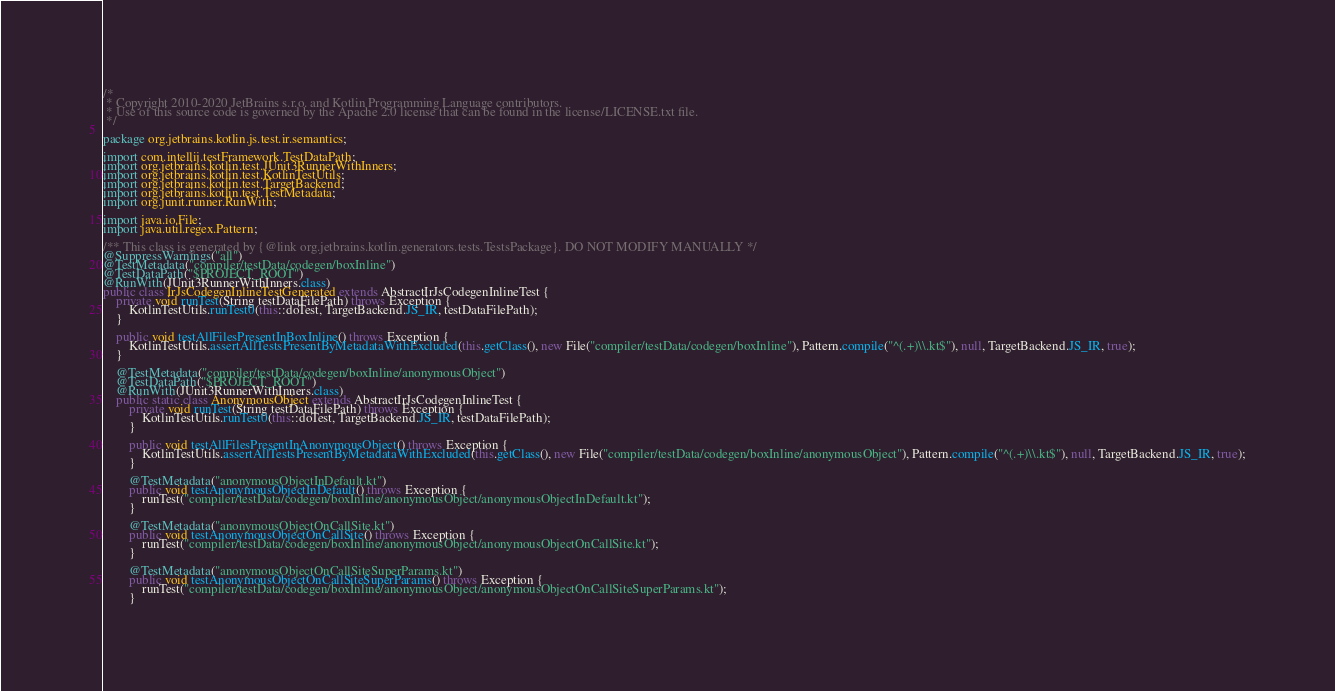Convert code to text. <code><loc_0><loc_0><loc_500><loc_500><_Java_>/*
 * Copyright 2010-2020 JetBrains s.r.o. and Kotlin Programming Language contributors.
 * Use of this source code is governed by the Apache 2.0 license that can be found in the license/LICENSE.txt file.
 */

package org.jetbrains.kotlin.js.test.ir.semantics;

import com.intellij.testFramework.TestDataPath;
import org.jetbrains.kotlin.test.JUnit3RunnerWithInners;
import org.jetbrains.kotlin.test.KotlinTestUtils;
import org.jetbrains.kotlin.test.TargetBackend;
import org.jetbrains.kotlin.test.TestMetadata;
import org.junit.runner.RunWith;

import java.io.File;
import java.util.regex.Pattern;

/** This class is generated by {@link org.jetbrains.kotlin.generators.tests.TestsPackage}. DO NOT MODIFY MANUALLY */
@SuppressWarnings("all")
@TestMetadata("compiler/testData/codegen/boxInline")
@TestDataPath("$PROJECT_ROOT")
@RunWith(JUnit3RunnerWithInners.class)
public class IrJsCodegenInlineTestGenerated extends AbstractIrJsCodegenInlineTest {
    private void runTest(String testDataFilePath) throws Exception {
        KotlinTestUtils.runTest0(this::doTest, TargetBackend.JS_IR, testDataFilePath);
    }

    public void testAllFilesPresentInBoxInline() throws Exception {
        KotlinTestUtils.assertAllTestsPresentByMetadataWithExcluded(this.getClass(), new File("compiler/testData/codegen/boxInline"), Pattern.compile("^(.+)\\.kt$"), null, TargetBackend.JS_IR, true);
    }

    @TestMetadata("compiler/testData/codegen/boxInline/anonymousObject")
    @TestDataPath("$PROJECT_ROOT")
    @RunWith(JUnit3RunnerWithInners.class)
    public static class AnonymousObject extends AbstractIrJsCodegenInlineTest {
        private void runTest(String testDataFilePath) throws Exception {
            KotlinTestUtils.runTest0(this::doTest, TargetBackend.JS_IR, testDataFilePath);
        }

        public void testAllFilesPresentInAnonymousObject() throws Exception {
            KotlinTestUtils.assertAllTestsPresentByMetadataWithExcluded(this.getClass(), new File("compiler/testData/codegen/boxInline/anonymousObject"), Pattern.compile("^(.+)\\.kt$"), null, TargetBackend.JS_IR, true);
        }

        @TestMetadata("anonymousObjectInDefault.kt")
        public void testAnonymousObjectInDefault() throws Exception {
            runTest("compiler/testData/codegen/boxInline/anonymousObject/anonymousObjectInDefault.kt");
        }

        @TestMetadata("anonymousObjectOnCallSite.kt")
        public void testAnonymousObjectOnCallSite() throws Exception {
            runTest("compiler/testData/codegen/boxInline/anonymousObject/anonymousObjectOnCallSite.kt");
        }

        @TestMetadata("anonymousObjectOnCallSiteSuperParams.kt")
        public void testAnonymousObjectOnCallSiteSuperParams() throws Exception {
            runTest("compiler/testData/codegen/boxInline/anonymousObject/anonymousObjectOnCallSiteSuperParams.kt");
        }
</code> 